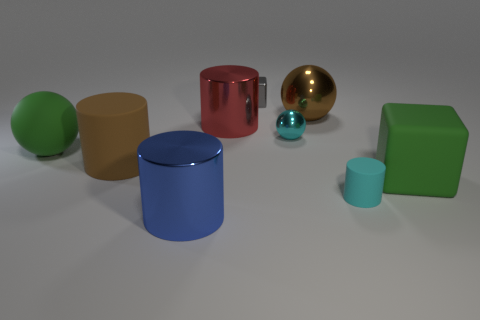What number of tiny things are either gray rubber cylinders or red shiny cylinders?
Provide a short and direct response. 0. Are there the same number of big green things on the left side of the large brown sphere and small metallic spheres that are right of the small cyan rubber cylinder?
Provide a short and direct response. No. What number of other things are there of the same color as the matte cube?
Make the answer very short. 1. There is a tiny matte cylinder; is it the same color as the tiny ball left of the matte cube?
Offer a terse response. Yes. How many brown things are big balls or big blocks?
Ensure brevity in your answer.  1. Are there the same number of big cylinders to the right of the tiny gray object and yellow metallic things?
Your answer should be very brief. Yes. There is a large rubber thing that is the same shape as the big blue shiny object; what is its color?
Your response must be concise. Brown. What number of tiny cyan objects have the same shape as the big red metal object?
Your response must be concise. 1. What is the material of the cylinder that is the same color as the tiny sphere?
Offer a terse response. Rubber. What number of big yellow matte spheres are there?
Provide a short and direct response. 0. 